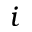Convert formula to latex. <formula><loc_0><loc_0><loc_500><loc_500>i</formula> 